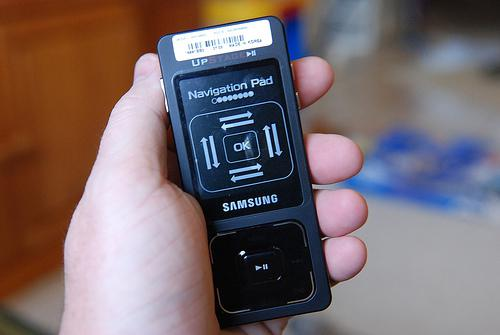Question: what company makes the electronic in the persons hand?
Choices:
A. Apple.
B. Sony.
C. Lg.
D. Samsung.
Answer with the letter. Answer: D Question: what sticker is on the top of the device?
Choices:
A. Price tag.
B. Name tag.
C. Advertisement.
D. Barcode.
Answer with the letter. Answer: D 